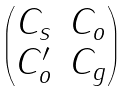<formula> <loc_0><loc_0><loc_500><loc_500>\begin{pmatrix} C _ { s } & C _ { o } \\ C ^ { \prime } _ { o } & C _ { g } \end{pmatrix}</formula> 